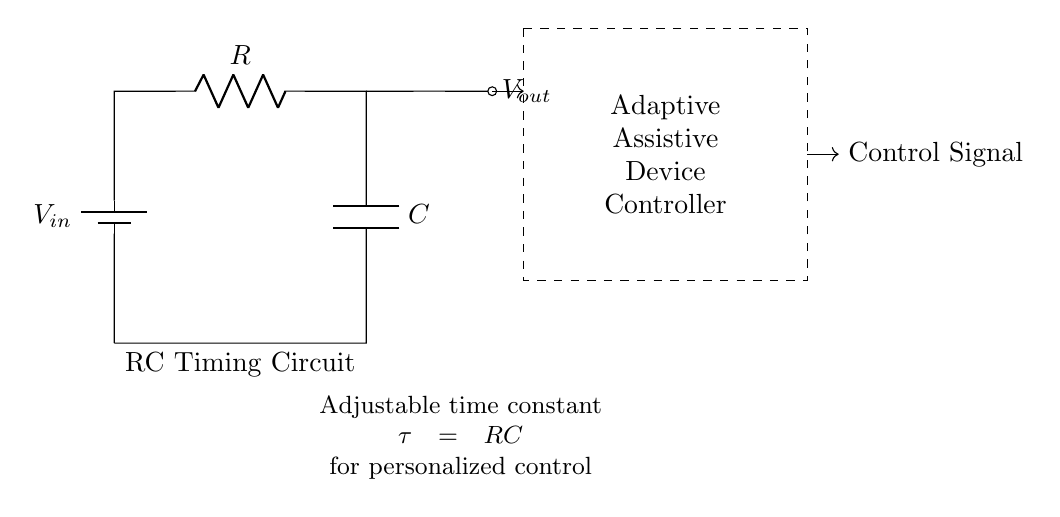What components are in this circuit? The circuit contains a battery, a resistor, and a capacitor, which are the basic components visible in the diagram.
Answer: battery, resistor, capacitor What does 'RC' stand for in this circuit? 'RC' stands for Resistor-Capacitor, indicating the type of timing circuit that utilizes these two components for timing applications.
Answer: Resistor-Capacitor What is represented by 'Vout'? 'Vout' represents the output voltage across the capacitor, which can be used in the adaptive assistive device control system.
Answer: output voltage What is the adjustable time constant denoted as? The adjustable time constant in this circuit is denoted as 'tau' and is expressed as the product of resistance and capacitance (RC).
Answer: tau How does the time constant affect the circuit behavior? The time constant, which is the product of resistance and capacitance, determines how quickly the capacitor charges or discharges, impacting the timing of the control signal.
Answer: RC timing Which component controls the timing in this circuit? The timing in this circuit is predominantly controlled by the combination of the resistor and the capacitor, known for their charging and discharging characteristics.
Answer: resistor and capacitor What is the main purpose of this RC timing circuit? The main purpose of this RC timing circuit is to provide a time delay or timing function that is adjustable for personalized control in the assistive device.
Answer: personalized control 